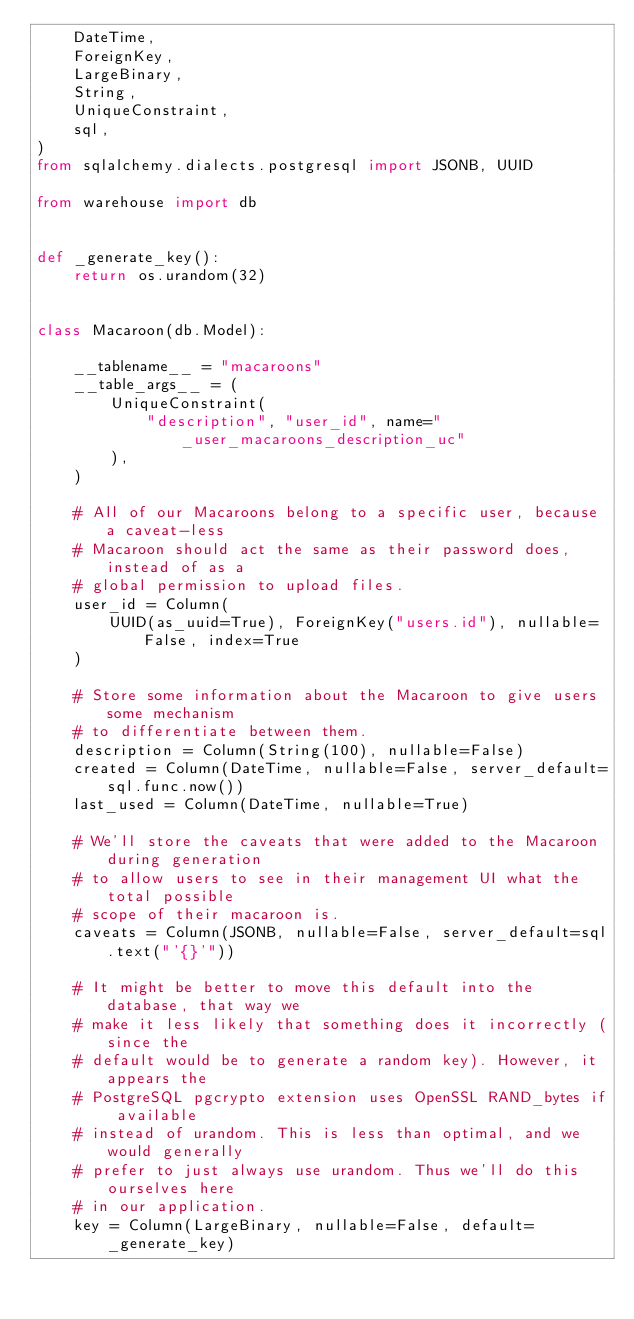Convert code to text. <code><loc_0><loc_0><loc_500><loc_500><_Python_>    DateTime,
    ForeignKey,
    LargeBinary,
    String,
    UniqueConstraint,
    sql,
)
from sqlalchemy.dialects.postgresql import JSONB, UUID

from warehouse import db


def _generate_key():
    return os.urandom(32)


class Macaroon(db.Model):

    __tablename__ = "macaroons"
    __table_args__ = (
        UniqueConstraint(
            "description", "user_id", name="_user_macaroons_description_uc"
        ),
    )

    # All of our Macaroons belong to a specific user, because a caveat-less
    # Macaroon should act the same as their password does, instead of as a
    # global permission to upload files.
    user_id = Column(
        UUID(as_uuid=True), ForeignKey("users.id"), nullable=False, index=True
    )

    # Store some information about the Macaroon to give users some mechanism
    # to differentiate between them.
    description = Column(String(100), nullable=False)
    created = Column(DateTime, nullable=False, server_default=sql.func.now())
    last_used = Column(DateTime, nullable=True)

    # We'll store the caveats that were added to the Macaroon during generation
    # to allow users to see in their management UI what the total possible
    # scope of their macaroon is.
    caveats = Column(JSONB, nullable=False, server_default=sql.text("'{}'"))

    # It might be better to move this default into the database, that way we
    # make it less likely that something does it incorrectly (since the
    # default would be to generate a random key). However, it appears the
    # PostgreSQL pgcrypto extension uses OpenSSL RAND_bytes if available
    # instead of urandom. This is less than optimal, and we would generally
    # prefer to just always use urandom. Thus we'll do this ourselves here
    # in our application.
    key = Column(LargeBinary, nullable=False, default=_generate_key)
</code> 